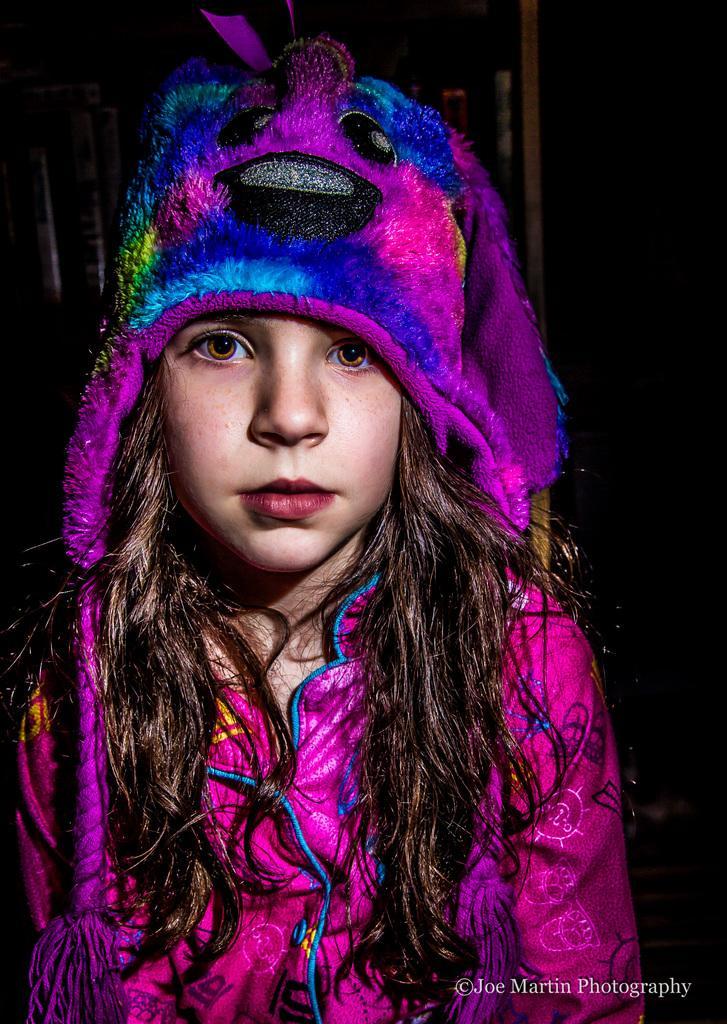In one or two sentences, can you explain what this image depicts? In the center of the image we can see a girl is there and wearing hat. At the bottom of the image some text is there. In the background the image is dark. 